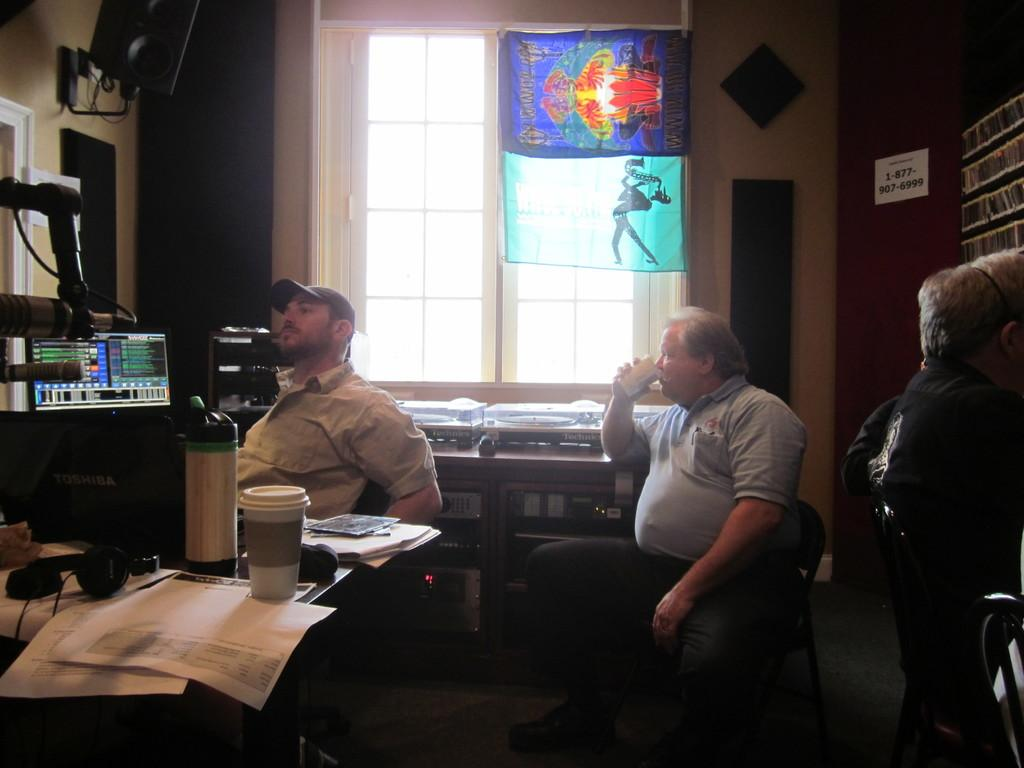How many people are sitting in the chairs in the image? There are two persons sitting on chairs in the image. What is in front of the chairs? There is a table in front of the chairs. What can be seen on the table? There are papers and objects on the table. What is visible in the room? There is a window in the room. How many ladybugs are crawling on the papers on the table? There are no ladybugs present on the papers or in the image. Are the two persons sitting on chairs brothers? The relationship between the two persons sitting on chairs is not mentioned in the image, so we cannot determine if they are brothers. 